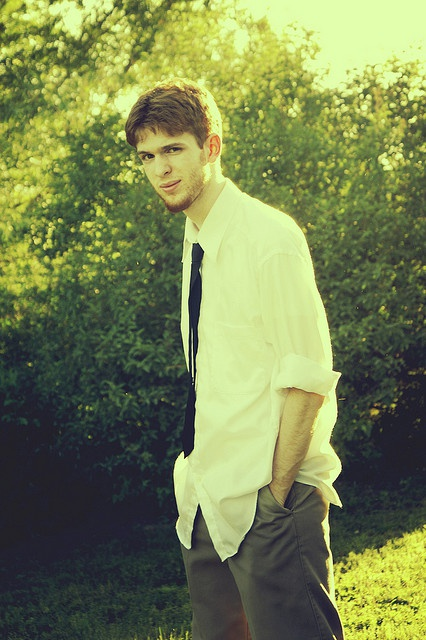Describe the objects in this image and their specific colors. I can see people in darkgreen, khaki, black, gray, and tan tones and tie in darkgreen, black, gray, and khaki tones in this image. 